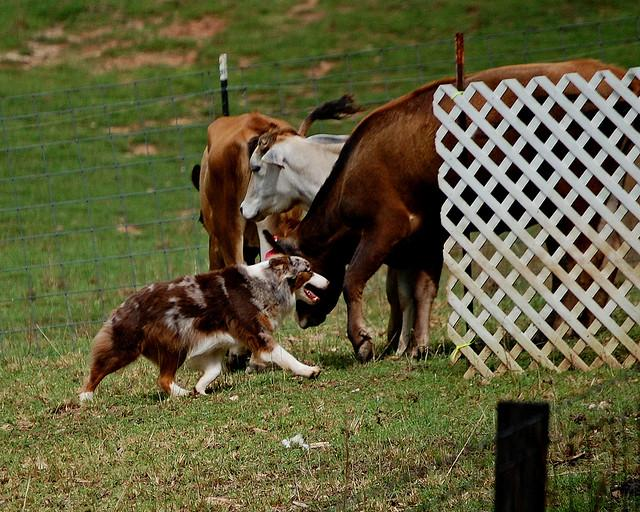What is a male of the larger animals called? bull 